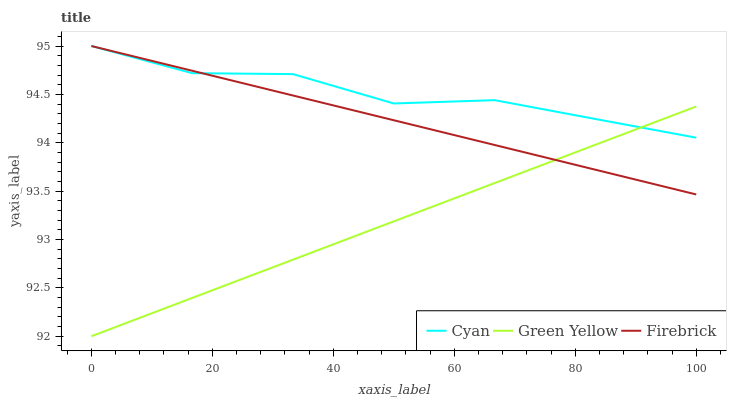Does Green Yellow have the minimum area under the curve?
Answer yes or no. Yes. Does Cyan have the maximum area under the curve?
Answer yes or no. Yes. Does Firebrick have the minimum area under the curve?
Answer yes or no. No. Does Firebrick have the maximum area under the curve?
Answer yes or no. No. Is Green Yellow the smoothest?
Answer yes or no. Yes. Is Cyan the roughest?
Answer yes or no. Yes. Is Firebrick the smoothest?
Answer yes or no. No. Is Firebrick the roughest?
Answer yes or no. No. Does Green Yellow have the lowest value?
Answer yes or no. Yes. Does Firebrick have the lowest value?
Answer yes or no. No. Does Firebrick have the highest value?
Answer yes or no. Yes. Does Green Yellow have the highest value?
Answer yes or no. No. Does Green Yellow intersect Cyan?
Answer yes or no. Yes. Is Green Yellow less than Cyan?
Answer yes or no. No. Is Green Yellow greater than Cyan?
Answer yes or no. No. 